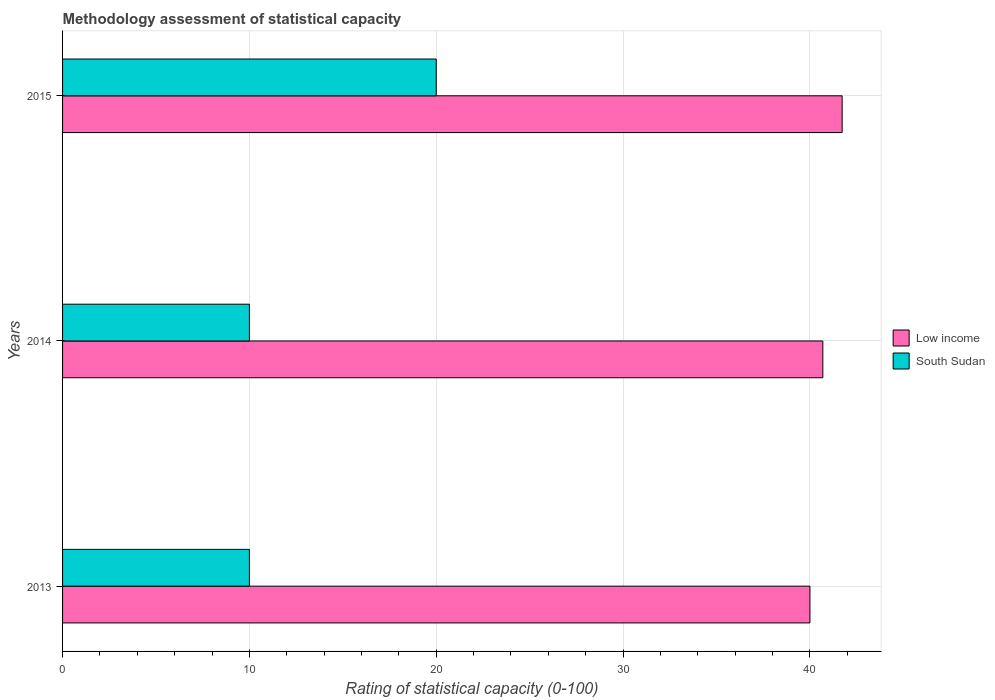Are the number of bars per tick equal to the number of legend labels?
Your answer should be compact. Yes. How many bars are there on the 1st tick from the bottom?
Provide a short and direct response. 2. What is the label of the 1st group of bars from the top?
Your response must be concise. 2015. What is the rating of statistical capacity in South Sudan in 2014?
Offer a terse response. 10. Across all years, what is the maximum rating of statistical capacity in Low income?
Your response must be concise. 41.72. In which year was the rating of statistical capacity in South Sudan maximum?
Keep it short and to the point. 2015. What is the total rating of statistical capacity in South Sudan in the graph?
Your answer should be very brief. 40. What is the difference between the rating of statistical capacity in South Sudan in 2013 and that in 2014?
Ensure brevity in your answer.  0. What is the difference between the rating of statistical capacity in Low income in 2014 and the rating of statistical capacity in South Sudan in 2013?
Your answer should be compact. 30.69. What is the average rating of statistical capacity in Low income per year?
Provide a succinct answer. 40.8. In the year 2015, what is the difference between the rating of statistical capacity in Low income and rating of statistical capacity in South Sudan?
Provide a short and direct response. 21.72. What is the ratio of the rating of statistical capacity in South Sudan in 2013 to that in 2015?
Offer a terse response. 0.5. What is the difference between the highest and the second highest rating of statistical capacity in Low income?
Your response must be concise. 1.03. What is the difference between the highest and the lowest rating of statistical capacity in Low income?
Offer a terse response. 1.72. In how many years, is the rating of statistical capacity in Low income greater than the average rating of statistical capacity in Low income taken over all years?
Keep it short and to the point. 1. Is the sum of the rating of statistical capacity in South Sudan in 2013 and 2014 greater than the maximum rating of statistical capacity in Low income across all years?
Give a very brief answer. No. What does the 2nd bar from the bottom in 2013 represents?
Your answer should be very brief. South Sudan. Are all the bars in the graph horizontal?
Provide a short and direct response. Yes. How many years are there in the graph?
Provide a succinct answer. 3. Are the values on the major ticks of X-axis written in scientific E-notation?
Keep it short and to the point. No. Where does the legend appear in the graph?
Offer a terse response. Center right. How are the legend labels stacked?
Give a very brief answer. Vertical. What is the title of the graph?
Provide a succinct answer. Methodology assessment of statistical capacity. Does "Botswana" appear as one of the legend labels in the graph?
Your response must be concise. No. What is the label or title of the X-axis?
Your answer should be compact. Rating of statistical capacity (0-100). What is the Rating of statistical capacity (0-100) of Low income in 2013?
Provide a short and direct response. 40. What is the Rating of statistical capacity (0-100) of South Sudan in 2013?
Provide a short and direct response. 10. What is the Rating of statistical capacity (0-100) in Low income in 2014?
Keep it short and to the point. 40.69. What is the Rating of statistical capacity (0-100) in South Sudan in 2014?
Make the answer very short. 10. What is the Rating of statistical capacity (0-100) in Low income in 2015?
Your answer should be compact. 41.72. Across all years, what is the maximum Rating of statistical capacity (0-100) of Low income?
Offer a very short reply. 41.72. Across all years, what is the minimum Rating of statistical capacity (0-100) in South Sudan?
Offer a terse response. 10. What is the total Rating of statistical capacity (0-100) of Low income in the graph?
Your response must be concise. 122.41. What is the difference between the Rating of statistical capacity (0-100) in Low income in 2013 and that in 2014?
Provide a succinct answer. -0.69. What is the difference between the Rating of statistical capacity (0-100) in South Sudan in 2013 and that in 2014?
Give a very brief answer. 0. What is the difference between the Rating of statistical capacity (0-100) of Low income in 2013 and that in 2015?
Your response must be concise. -1.72. What is the difference between the Rating of statistical capacity (0-100) in South Sudan in 2013 and that in 2015?
Your response must be concise. -10. What is the difference between the Rating of statistical capacity (0-100) in Low income in 2014 and that in 2015?
Provide a succinct answer. -1.03. What is the difference between the Rating of statistical capacity (0-100) of Low income in 2013 and the Rating of statistical capacity (0-100) of South Sudan in 2015?
Ensure brevity in your answer.  20. What is the difference between the Rating of statistical capacity (0-100) of Low income in 2014 and the Rating of statistical capacity (0-100) of South Sudan in 2015?
Your answer should be compact. 20.69. What is the average Rating of statistical capacity (0-100) in Low income per year?
Your response must be concise. 40.8. What is the average Rating of statistical capacity (0-100) of South Sudan per year?
Give a very brief answer. 13.33. In the year 2014, what is the difference between the Rating of statistical capacity (0-100) in Low income and Rating of statistical capacity (0-100) in South Sudan?
Your response must be concise. 30.69. In the year 2015, what is the difference between the Rating of statistical capacity (0-100) in Low income and Rating of statistical capacity (0-100) in South Sudan?
Offer a very short reply. 21.72. What is the ratio of the Rating of statistical capacity (0-100) of Low income in 2013 to that in 2014?
Offer a terse response. 0.98. What is the ratio of the Rating of statistical capacity (0-100) in Low income in 2013 to that in 2015?
Provide a succinct answer. 0.96. What is the ratio of the Rating of statistical capacity (0-100) of Low income in 2014 to that in 2015?
Keep it short and to the point. 0.98. What is the ratio of the Rating of statistical capacity (0-100) of South Sudan in 2014 to that in 2015?
Provide a short and direct response. 0.5. What is the difference between the highest and the second highest Rating of statistical capacity (0-100) of Low income?
Provide a short and direct response. 1.03. What is the difference between the highest and the lowest Rating of statistical capacity (0-100) in Low income?
Provide a short and direct response. 1.72. 